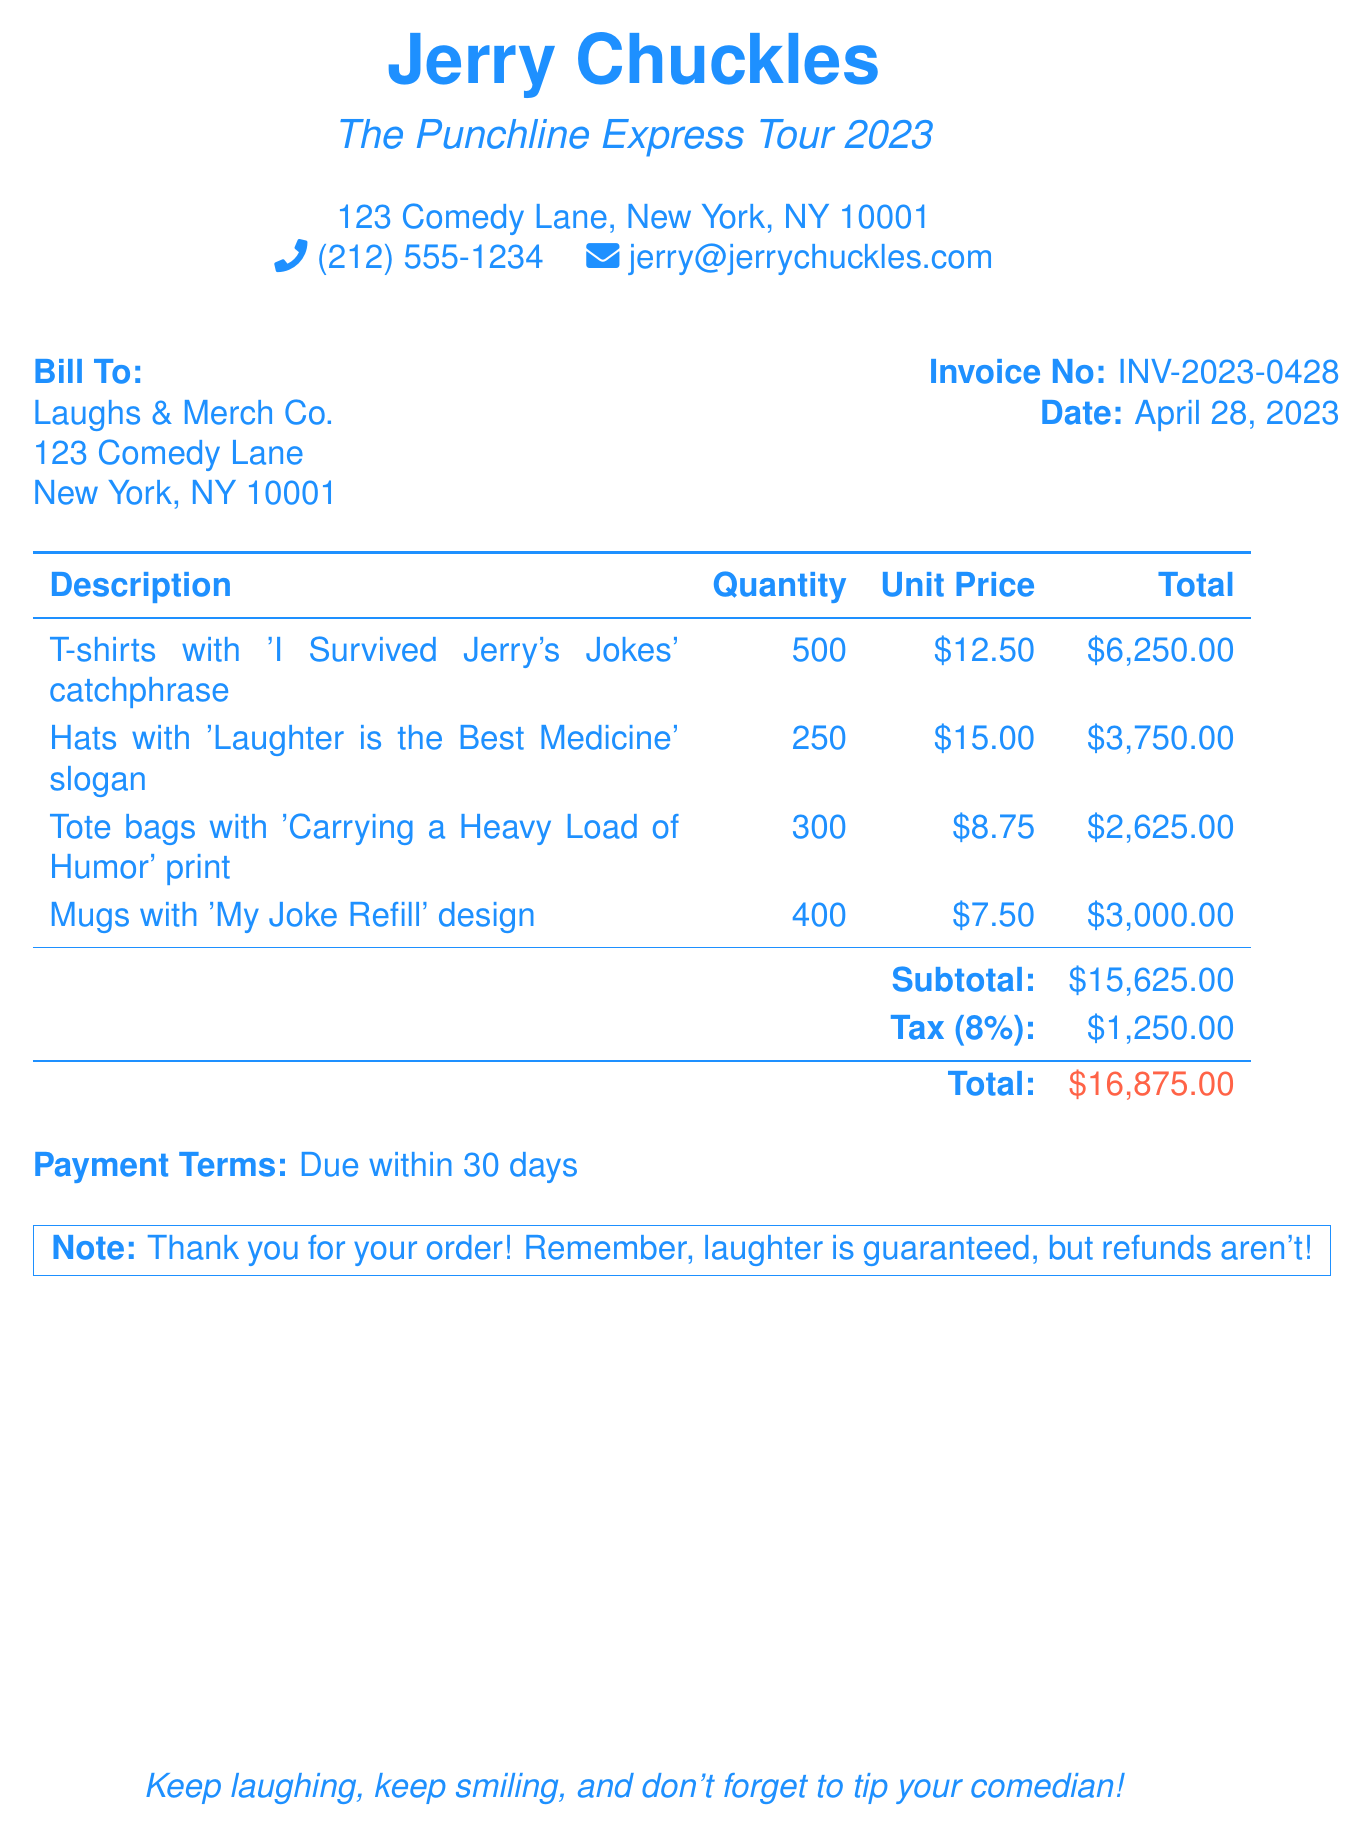What is the total amount due? The total amount due is stated at the bottom of the invoice, which includes the subtotal and tax.
Answer: $16,875.00 What is the invoice number? The invoice number is mentioned near the top right of the document.
Answer: INV-2023-0428 How much are the hats being billed for? The total cost for the hats is mentioned in the table under the total column.
Answer: $3,750.00 What is the quantity of T-shirts ordered? The quantity of T-shirts is listed next to the description in the invoice table.
Answer: 500 What is the tax percentage applied? The tax percentage is specified in the invoice near the total amount.
Answer: 8% What is the catchphrase on the tote bags? The catchphrase for the tote bags is stated alongside the item description.
Answer: Carrying a Heavy Load of Humor What are the payment terms? The payment terms are outlined at the bottom of the document.
Answer: Due within 30 days What is the address of the billing recipient? The billing recipient's address is listed under "Bill To."
Answer: 123 Comedy Lane, New York, NY 10001 What is included in the note section of the bill? The note section expresses appreciation for the order and the refund policy.
Answer: Thank you for your order! Remember, laughter is guaranteed, but refunds aren't! 